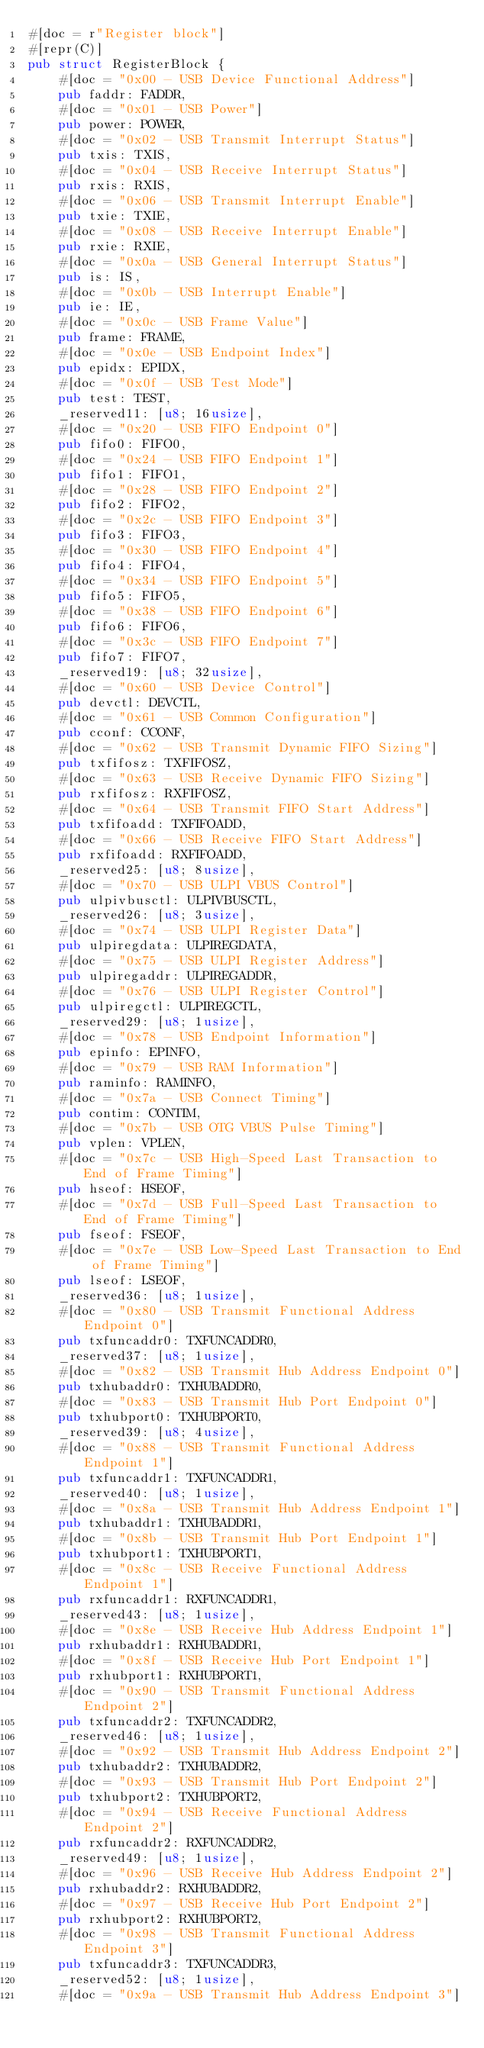Convert code to text. <code><loc_0><loc_0><loc_500><loc_500><_Rust_>#[doc = r"Register block"]
#[repr(C)]
pub struct RegisterBlock {
    #[doc = "0x00 - USB Device Functional Address"]
    pub faddr: FADDR,
    #[doc = "0x01 - USB Power"]
    pub power: POWER,
    #[doc = "0x02 - USB Transmit Interrupt Status"]
    pub txis: TXIS,
    #[doc = "0x04 - USB Receive Interrupt Status"]
    pub rxis: RXIS,
    #[doc = "0x06 - USB Transmit Interrupt Enable"]
    pub txie: TXIE,
    #[doc = "0x08 - USB Receive Interrupt Enable"]
    pub rxie: RXIE,
    #[doc = "0x0a - USB General Interrupt Status"]
    pub is: IS,
    #[doc = "0x0b - USB Interrupt Enable"]
    pub ie: IE,
    #[doc = "0x0c - USB Frame Value"]
    pub frame: FRAME,
    #[doc = "0x0e - USB Endpoint Index"]
    pub epidx: EPIDX,
    #[doc = "0x0f - USB Test Mode"]
    pub test: TEST,
    _reserved11: [u8; 16usize],
    #[doc = "0x20 - USB FIFO Endpoint 0"]
    pub fifo0: FIFO0,
    #[doc = "0x24 - USB FIFO Endpoint 1"]
    pub fifo1: FIFO1,
    #[doc = "0x28 - USB FIFO Endpoint 2"]
    pub fifo2: FIFO2,
    #[doc = "0x2c - USB FIFO Endpoint 3"]
    pub fifo3: FIFO3,
    #[doc = "0x30 - USB FIFO Endpoint 4"]
    pub fifo4: FIFO4,
    #[doc = "0x34 - USB FIFO Endpoint 5"]
    pub fifo5: FIFO5,
    #[doc = "0x38 - USB FIFO Endpoint 6"]
    pub fifo6: FIFO6,
    #[doc = "0x3c - USB FIFO Endpoint 7"]
    pub fifo7: FIFO7,
    _reserved19: [u8; 32usize],
    #[doc = "0x60 - USB Device Control"]
    pub devctl: DEVCTL,
    #[doc = "0x61 - USB Common Configuration"]
    pub cconf: CCONF,
    #[doc = "0x62 - USB Transmit Dynamic FIFO Sizing"]
    pub txfifosz: TXFIFOSZ,
    #[doc = "0x63 - USB Receive Dynamic FIFO Sizing"]
    pub rxfifosz: RXFIFOSZ,
    #[doc = "0x64 - USB Transmit FIFO Start Address"]
    pub txfifoadd: TXFIFOADD,
    #[doc = "0x66 - USB Receive FIFO Start Address"]
    pub rxfifoadd: RXFIFOADD,
    _reserved25: [u8; 8usize],
    #[doc = "0x70 - USB ULPI VBUS Control"]
    pub ulpivbusctl: ULPIVBUSCTL,
    _reserved26: [u8; 3usize],
    #[doc = "0x74 - USB ULPI Register Data"]
    pub ulpiregdata: ULPIREGDATA,
    #[doc = "0x75 - USB ULPI Register Address"]
    pub ulpiregaddr: ULPIREGADDR,
    #[doc = "0x76 - USB ULPI Register Control"]
    pub ulpiregctl: ULPIREGCTL,
    _reserved29: [u8; 1usize],
    #[doc = "0x78 - USB Endpoint Information"]
    pub epinfo: EPINFO,
    #[doc = "0x79 - USB RAM Information"]
    pub raminfo: RAMINFO,
    #[doc = "0x7a - USB Connect Timing"]
    pub contim: CONTIM,
    #[doc = "0x7b - USB OTG VBUS Pulse Timing"]
    pub vplen: VPLEN,
    #[doc = "0x7c - USB High-Speed Last Transaction to End of Frame Timing"]
    pub hseof: HSEOF,
    #[doc = "0x7d - USB Full-Speed Last Transaction to End of Frame Timing"]
    pub fseof: FSEOF,
    #[doc = "0x7e - USB Low-Speed Last Transaction to End of Frame Timing"]
    pub lseof: LSEOF,
    _reserved36: [u8; 1usize],
    #[doc = "0x80 - USB Transmit Functional Address Endpoint 0"]
    pub txfuncaddr0: TXFUNCADDR0,
    _reserved37: [u8; 1usize],
    #[doc = "0x82 - USB Transmit Hub Address Endpoint 0"]
    pub txhubaddr0: TXHUBADDR0,
    #[doc = "0x83 - USB Transmit Hub Port Endpoint 0"]
    pub txhubport0: TXHUBPORT0,
    _reserved39: [u8; 4usize],
    #[doc = "0x88 - USB Transmit Functional Address Endpoint 1"]
    pub txfuncaddr1: TXFUNCADDR1,
    _reserved40: [u8; 1usize],
    #[doc = "0x8a - USB Transmit Hub Address Endpoint 1"]
    pub txhubaddr1: TXHUBADDR1,
    #[doc = "0x8b - USB Transmit Hub Port Endpoint 1"]
    pub txhubport1: TXHUBPORT1,
    #[doc = "0x8c - USB Receive Functional Address Endpoint 1"]
    pub rxfuncaddr1: RXFUNCADDR1,
    _reserved43: [u8; 1usize],
    #[doc = "0x8e - USB Receive Hub Address Endpoint 1"]
    pub rxhubaddr1: RXHUBADDR1,
    #[doc = "0x8f - USB Receive Hub Port Endpoint 1"]
    pub rxhubport1: RXHUBPORT1,
    #[doc = "0x90 - USB Transmit Functional Address Endpoint 2"]
    pub txfuncaddr2: TXFUNCADDR2,
    _reserved46: [u8; 1usize],
    #[doc = "0x92 - USB Transmit Hub Address Endpoint 2"]
    pub txhubaddr2: TXHUBADDR2,
    #[doc = "0x93 - USB Transmit Hub Port Endpoint 2"]
    pub txhubport2: TXHUBPORT2,
    #[doc = "0x94 - USB Receive Functional Address Endpoint 2"]
    pub rxfuncaddr2: RXFUNCADDR2,
    _reserved49: [u8; 1usize],
    #[doc = "0x96 - USB Receive Hub Address Endpoint 2"]
    pub rxhubaddr2: RXHUBADDR2,
    #[doc = "0x97 - USB Receive Hub Port Endpoint 2"]
    pub rxhubport2: RXHUBPORT2,
    #[doc = "0x98 - USB Transmit Functional Address Endpoint 3"]
    pub txfuncaddr3: TXFUNCADDR3,
    _reserved52: [u8; 1usize],
    #[doc = "0x9a - USB Transmit Hub Address Endpoint 3"]</code> 